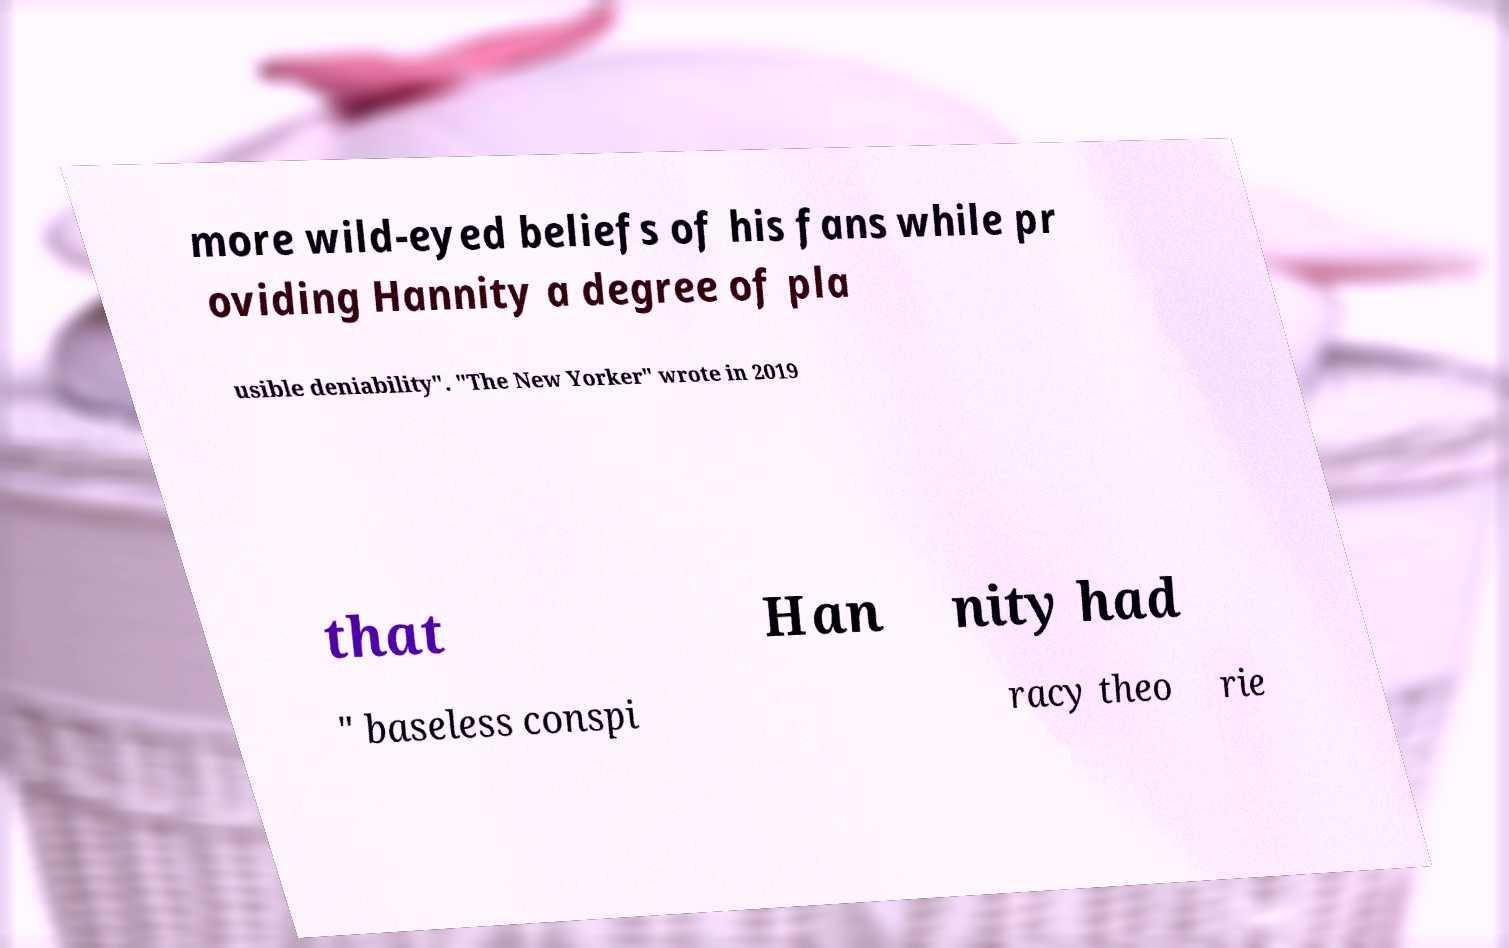There's text embedded in this image that I need extracted. Can you transcribe it verbatim? more wild-eyed beliefs of his fans while pr oviding Hannity a degree of pla usible deniability". "The New Yorker" wrote in 2019 that Han nity had " baseless conspi racy theo rie 